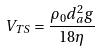<formula> <loc_0><loc_0><loc_500><loc_500>V _ { T S } = \frac { \rho _ { 0 } d _ { a } ^ { 2 } g } { 1 8 \eta }</formula> 